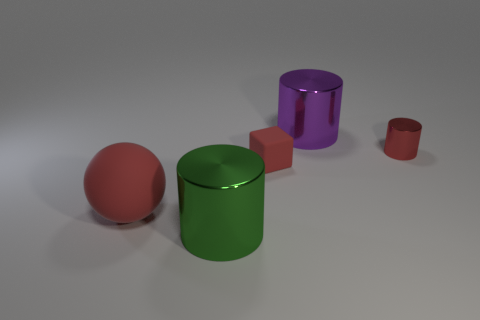Is there any other thing that is the same shape as the large red object?
Your response must be concise. No. There is a cylinder that is the same color as the matte cube; what material is it?
Your answer should be very brief. Metal. What number of things are left of the green metal cylinder and behind the red shiny cylinder?
Your answer should be compact. 0. What material is the tiny thing to the left of the big cylinder behind the big green object made of?
Provide a short and direct response. Rubber. Is there a big object made of the same material as the red block?
Offer a very short reply. Yes. There is a green cylinder that is the same size as the matte ball; what is it made of?
Give a very brief answer. Metal. There is a cylinder in front of the big thing left of the cylinder on the left side of the small rubber block; how big is it?
Your answer should be very brief. Large. Are there any red things on the left side of the big cylinder that is behind the red shiny cylinder?
Give a very brief answer. Yes. There is a red metal thing; does it have the same shape as the thing that is in front of the big rubber ball?
Provide a short and direct response. Yes. There is a metal thing in front of the big sphere; what color is it?
Ensure brevity in your answer.  Green. 